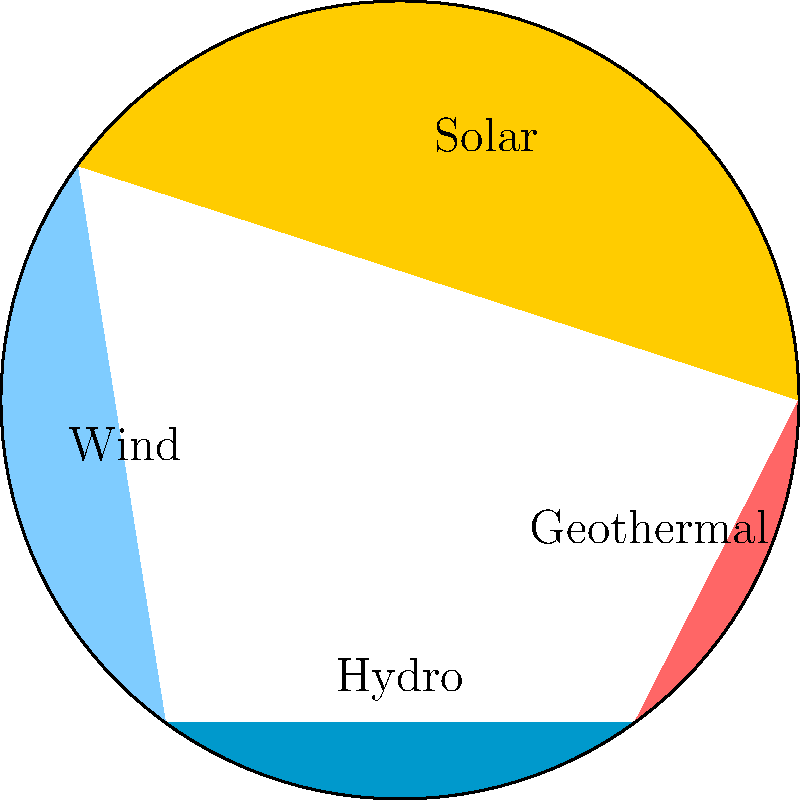Based on the pie chart showing the distribution of carbon emission reduction through various clean energy technologies, which two technologies combined account for 65% of the total reduction? To solve this question, we need to analyze the pie chart and sum up the percentages for different combinations of technologies until we find the pair that adds up to 65%. Let's go through this step-by-step:

1. The pie chart shows four clean energy technologies: Solar, Wind, Hydro, and Geothermal.

2. We need to find two technologies that together account for 65% of the total reduction.

3. Let's start with the largest slice and work our way down:

   Solar: 40%
   Wind: 25%
   Hydro: 20%
   Geothermal: 15%

4. Combining Solar (40%) and Wind (25%):
   $40\% + 25\% = 65\%$

5. We've found our answer: Solar and Wind together account for 65% of the total carbon emission reduction.

6. For verification, let's check other combinations:
   Solar + Hydro = 60%
   Solar + Geothermal = 55%
   Wind + Hydro = 45%
   Wind + Geothermal = 40%
   Hydro + Geothermal = 35%

None of these other combinations add up to 65%.
Answer: Solar and Wind 